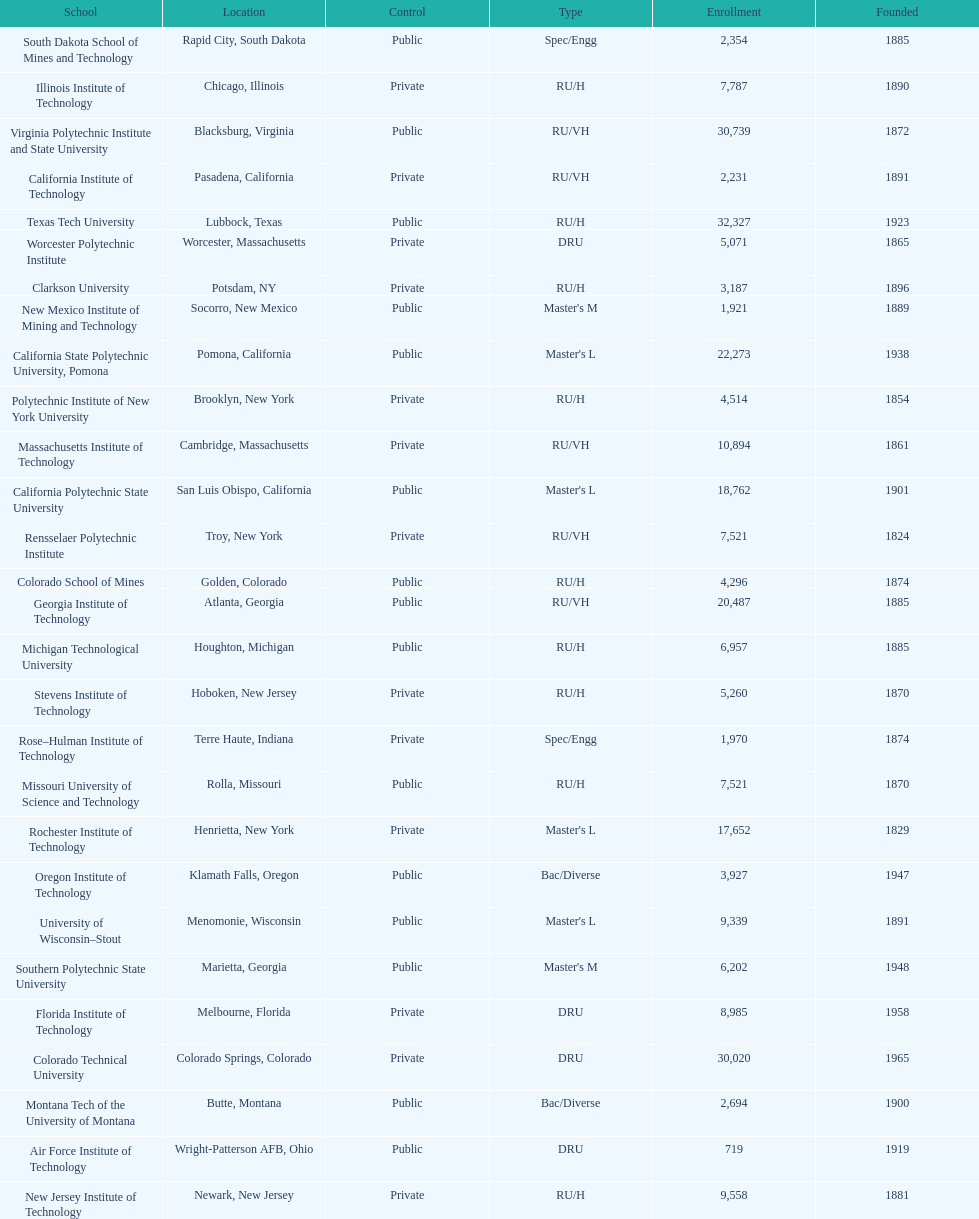What is the difference in enrollment between the top 2 schools listed in the table? 1512. Give me the full table as a dictionary. {'header': ['School', 'Location', 'Control', 'Type', 'Enrollment', 'Founded'], 'rows': [['South Dakota School of Mines and Technology', 'Rapid City, South Dakota', 'Public', 'Spec/Engg', '2,354', '1885'], ['Illinois Institute of Technology', 'Chicago, Illinois', 'Private', 'RU/H', '7,787', '1890'], ['Virginia Polytechnic Institute and State University', 'Blacksburg, Virginia', 'Public', 'RU/VH', '30,739', '1872'], ['California Institute of Technology', 'Pasadena, California', 'Private', 'RU/VH', '2,231', '1891'], ['Texas Tech University', 'Lubbock, Texas', 'Public', 'RU/H', '32,327', '1923'], ['Worcester Polytechnic Institute', 'Worcester, Massachusetts', 'Private', 'DRU', '5,071', '1865'], ['Clarkson University', 'Potsdam, NY', 'Private', 'RU/H', '3,187', '1896'], ['New Mexico Institute of Mining and Technology', 'Socorro, New Mexico', 'Public', "Master's M", '1,921', '1889'], ['California State Polytechnic University, Pomona', 'Pomona, California', 'Public', "Master's L", '22,273', '1938'], ['Polytechnic Institute of New York University', 'Brooklyn, New York', 'Private', 'RU/H', '4,514', '1854'], ['Massachusetts Institute of Technology', 'Cambridge, Massachusetts', 'Private', 'RU/VH', '10,894', '1861'], ['California Polytechnic State University', 'San Luis Obispo, California', 'Public', "Master's L", '18,762', '1901'], ['Rensselaer Polytechnic Institute', 'Troy, New York', 'Private', 'RU/VH', '7,521', '1824'], ['Colorado School of Mines', 'Golden, Colorado', 'Public', 'RU/H', '4,296', '1874'], ['Georgia Institute of Technology', 'Atlanta, Georgia', 'Public', 'RU/VH', '20,487', '1885'], ['Michigan Technological University', 'Houghton, Michigan', 'Public', 'RU/H', '6,957', '1885'], ['Stevens Institute of Technology', 'Hoboken, New Jersey', 'Private', 'RU/H', '5,260', '1870'], ['Rose–Hulman Institute of Technology', 'Terre Haute, Indiana', 'Private', 'Spec/Engg', '1,970', '1874'], ['Missouri University of Science and Technology', 'Rolla, Missouri', 'Public', 'RU/H', '7,521', '1870'], ['Rochester Institute of Technology', 'Henrietta, New York', 'Private', "Master's L", '17,652', '1829'], ['Oregon Institute of Technology', 'Klamath Falls, Oregon', 'Public', 'Bac/Diverse', '3,927', '1947'], ['University of Wisconsin–Stout', 'Menomonie, Wisconsin', 'Public', "Master's L", '9,339', '1891'], ['Southern Polytechnic State University', 'Marietta, Georgia', 'Public', "Master's M", '6,202', '1948'], ['Florida Institute of Technology', 'Melbourne, Florida', 'Private', 'DRU', '8,985', '1958'], ['Colorado Technical University', 'Colorado Springs, Colorado', 'Private', 'DRU', '30,020', '1965'], ['Montana Tech of the University of Montana', 'Butte, Montana', 'Public', 'Bac/Diverse', '2,694', '1900'], ['Air Force Institute of Technology', 'Wright-Patterson AFB, Ohio', 'Public', 'DRU', '719', '1919'], ['New Jersey Institute of Technology', 'Newark, New Jersey', 'Private', 'RU/H', '9,558', '1881']]} 